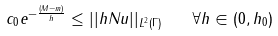Convert formula to latex. <formula><loc_0><loc_0><loc_500><loc_500>c _ { 0 } e ^ { - \frac { ( M - m ) } { h } } \leq | | h N u | | _ { L ^ { 2 } ( \Gamma ) } \quad \forall h \in ( 0 , h _ { 0 } )</formula> 